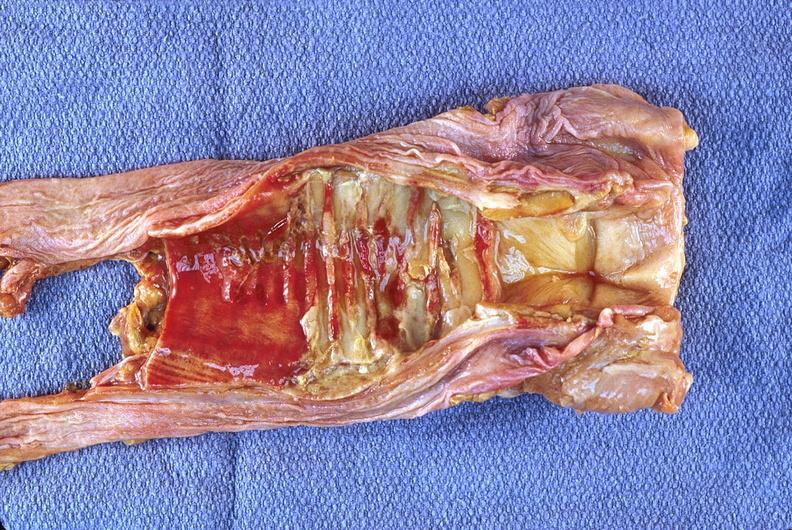does color show trachea, necrotizing tracheitis?
Answer the question using a single word or phrase. No 